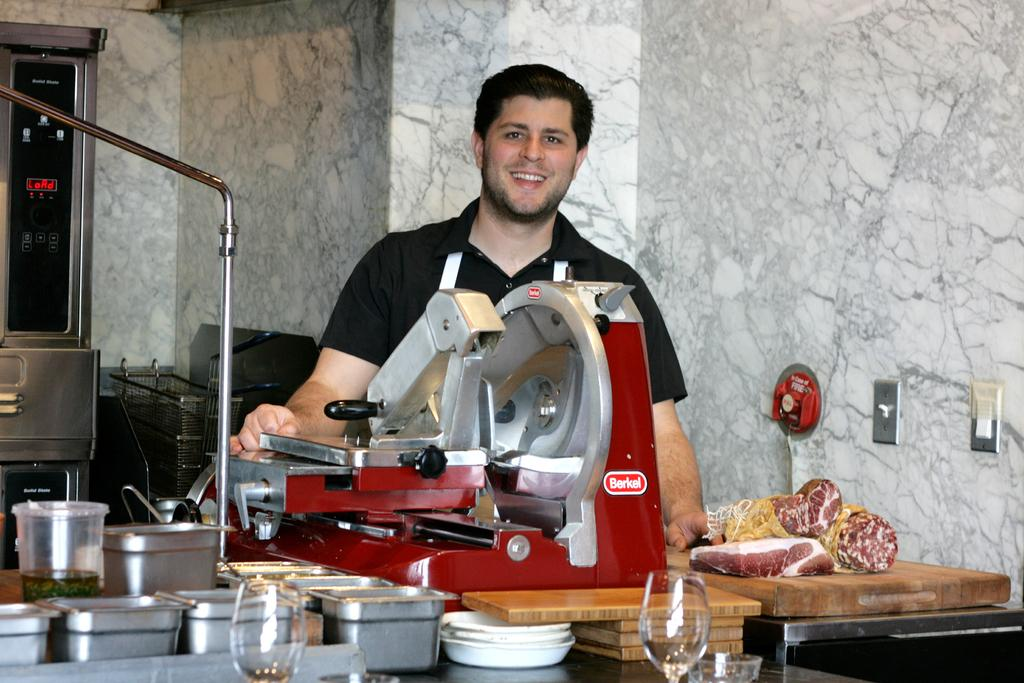Provide a one-sentence caption for the provided image. The chief only uses Berkel meat slicer, to slice his meat. 